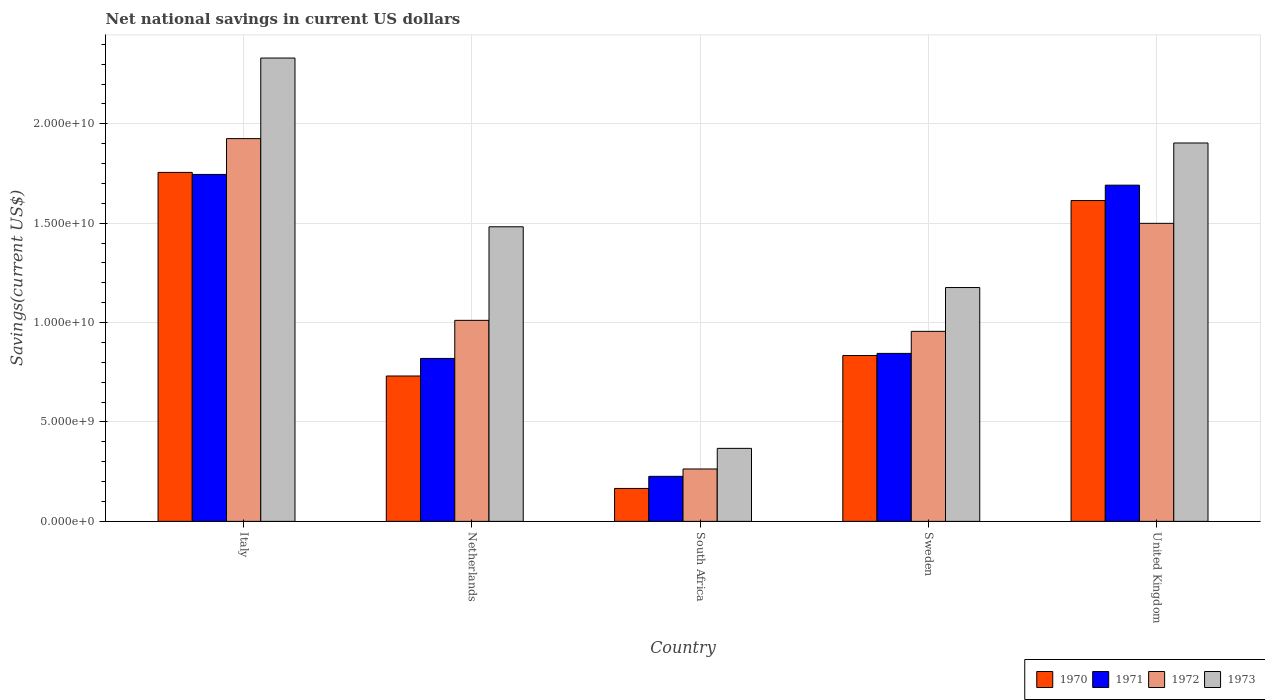How many different coloured bars are there?
Provide a short and direct response. 4. How many groups of bars are there?
Provide a succinct answer. 5. How many bars are there on the 2nd tick from the left?
Offer a terse response. 4. In how many cases, is the number of bars for a given country not equal to the number of legend labels?
Offer a terse response. 0. What is the net national savings in 1973 in Sweden?
Provide a succinct answer. 1.18e+1. Across all countries, what is the maximum net national savings in 1970?
Ensure brevity in your answer.  1.76e+1. Across all countries, what is the minimum net national savings in 1973?
Your response must be concise. 3.67e+09. In which country was the net national savings in 1970 maximum?
Offer a terse response. Italy. In which country was the net national savings in 1973 minimum?
Your answer should be compact. South Africa. What is the total net national savings in 1970 in the graph?
Your response must be concise. 5.10e+1. What is the difference between the net national savings in 1973 in South Africa and that in Sweden?
Ensure brevity in your answer.  -8.09e+09. What is the difference between the net national savings in 1972 in Sweden and the net national savings in 1973 in United Kingdom?
Make the answer very short. -9.48e+09. What is the average net national savings in 1971 per country?
Ensure brevity in your answer.  1.07e+1. What is the difference between the net national savings of/in 1971 and net national savings of/in 1972 in Italy?
Provide a short and direct response. -1.80e+09. In how many countries, is the net national savings in 1973 greater than 3000000000 US$?
Provide a succinct answer. 5. What is the ratio of the net national savings in 1972 in Netherlands to that in Sweden?
Your answer should be very brief. 1.06. Is the difference between the net national savings in 1971 in Italy and United Kingdom greater than the difference between the net national savings in 1972 in Italy and United Kingdom?
Offer a very short reply. No. What is the difference between the highest and the second highest net national savings in 1971?
Your answer should be compact. 5.40e+08. What is the difference between the highest and the lowest net national savings in 1972?
Offer a very short reply. 1.66e+1. In how many countries, is the net national savings in 1970 greater than the average net national savings in 1970 taken over all countries?
Make the answer very short. 2. Is it the case that in every country, the sum of the net national savings in 1971 and net national savings in 1972 is greater than the sum of net national savings in 1973 and net national savings in 1970?
Your answer should be compact. No. How many bars are there?
Provide a succinct answer. 20. Are all the bars in the graph horizontal?
Keep it short and to the point. No. What is the difference between two consecutive major ticks on the Y-axis?
Provide a succinct answer. 5.00e+09. How many legend labels are there?
Ensure brevity in your answer.  4. How are the legend labels stacked?
Your answer should be very brief. Horizontal. What is the title of the graph?
Offer a very short reply. Net national savings in current US dollars. What is the label or title of the X-axis?
Your answer should be very brief. Country. What is the label or title of the Y-axis?
Your answer should be compact. Savings(current US$). What is the Savings(current US$) of 1970 in Italy?
Provide a succinct answer. 1.76e+1. What is the Savings(current US$) of 1971 in Italy?
Offer a very short reply. 1.75e+1. What is the Savings(current US$) of 1972 in Italy?
Give a very brief answer. 1.93e+1. What is the Savings(current US$) in 1973 in Italy?
Give a very brief answer. 2.33e+1. What is the Savings(current US$) of 1970 in Netherlands?
Provide a succinct answer. 7.31e+09. What is the Savings(current US$) in 1971 in Netherlands?
Make the answer very short. 8.20e+09. What is the Savings(current US$) in 1972 in Netherlands?
Your answer should be very brief. 1.01e+1. What is the Savings(current US$) in 1973 in Netherlands?
Give a very brief answer. 1.48e+1. What is the Savings(current US$) of 1970 in South Africa?
Ensure brevity in your answer.  1.66e+09. What is the Savings(current US$) of 1971 in South Africa?
Ensure brevity in your answer.  2.27e+09. What is the Savings(current US$) of 1972 in South Africa?
Offer a terse response. 2.64e+09. What is the Savings(current US$) in 1973 in South Africa?
Your answer should be very brief. 3.67e+09. What is the Savings(current US$) in 1970 in Sweden?
Your answer should be very brief. 8.34e+09. What is the Savings(current US$) in 1971 in Sweden?
Provide a short and direct response. 8.45e+09. What is the Savings(current US$) in 1972 in Sweden?
Give a very brief answer. 9.56e+09. What is the Savings(current US$) in 1973 in Sweden?
Offer a terse response. 1.18e+1. What is the Savings(current US$) of 1970 in United Kingdom?
Give a very brief answer. 1.61e+1. What is the Savings(current US$) of 1971 in United Kingdom?
Your response must be concise. 1.69e+1. What is the Savings(current US$) in 1972 in United Kingdom?
Make the answer very short. 1.50e+1. What is the Savings(current US$) of 1973 in United Kingdom?
Your answer should be compact. 1.90e+1. Across all countries, what is the maximum Savings(current US$) of 1970?
Your answer should be very brief. 1.76e+1. Across all countries, what is the maximum Savings(current US$) in 1971?
Give a very brief answer. 1.75e+1. Across all countries, what is the maximum Savings(current US$) in 1972?
Ensure brevity in your answer.  1.93e+1. Across all countries, what is the maximum Savings(current US$) of 1973?
Your answer should be compact. 2.33e+1. Across all countries, what is the minimum Savings(current US$) of 1970?
Provide a succinct answer. 1.66e+09. Across all countries, what is the minimum Savings(current US$) in 1971?
Your answer should be very brief. 2.27e+09. Across all countries, what is the minimum Savings(current US$) in 1972?
Provide a succinct answer. 2.64e+09. Across all countries, what is the minimum Savings(current US$) of 1973?
Offer a terse response. 3.67e+09. What is the total Savings(current US$) in 1970 in the graph?
Keep it short and to the point. 5.10e+1. What is the total Savings(current US$) in 1971 in the graph?
Your answer should be compact. 5.33e+1. What is the total Savings(current US$) in 1972 in the graph?
Keep it short and to the point. 5.66e+1. What is the total Savings(current US$) in 1973 in the graph?
Provide a succinct answer. 7.26e+1. What is the difference between the Savings(current US$) in 1970 in Italy and that in Netherlands?
Your answer should be very brief. 1.02e+1. What is the difference between the Savings(current US$) in 1971 in Italy and that in Netherlands?
Offer a very short reply. 9.26e+09. What is the difference between the Savings(current US$) in 1972 in Italy and that in Netherlands?
Make the answer very short. 9.14e+09. What is the difference between the Savings(current US$) of 1973 in Italy and that in Netherlands?
Offer a terse response. 8.49e+09. What is the difference between the Savings(current US$) in 1970 in Italy and that in South Africa?
Make the answer very short. 1.59e+1. What is the difference between the Savings(current US$) in 1971 in Italy and that in South Africa?
Offer a terse response. 1.52e+1. What is the difference between the Savings(current US$) in 1972 in Italy and that in South Africa?
Your answer should be very brief. 1.66e+1. What is the difference between the Savings(current US$) in 1973 in Italy and that in South Africa?
Your answer should be compact. 1.96e+1. What is the difference between the Savings(current US$) in 1970 in Italy and that in Sweden?
Ensure brevity in your answer.  9.21e+09. What is the difference between the Savings(current US$) in 1971 in Italy and that in Sweden?
Your response must be concise. 9.00e+09. What is the difference between the Savings(current US$) of 1972 in Italy and that in Sweden?
Give a very brief answer. 9.70e+09. What is the difference between the Savings(current US$) of 1973 in Italy and that in Sweden?
Your answer should be compact. 1.15e+1. What is the difference between the Savings(current US$) in 1970 in Italy and that in United Kingdom?
Ensure brevity in your answer.  1.42e+09. What is the difference between the Savings(current US$) in 1971 in Italy and that in United Kingdom?
Give a very brief answer. 5.40e+08. What is the difference between the Savings(current US$) in 1972 in Italy and that in United Kingdom?
Provide a short and direct response. 4.26e+09. What is the difference between the Savings(current US$) of 1973 in Italy and that in United Kingdom?
Offer a very short reply. 4.27e+09. What is the difference between the Savings(current US$) in 1970 in Netherlands and that in South Africa?
Keep it short and to the point. 5.66e+09. What is the difference between the Savings(current US$) of 1971 in Netherlands and that in South Africa?
Keep it short and to the point. 5.93e+09. What is the difference between the Savings(current US$) in 1972 in Netherlands and that in South Africa?
Ensure brevity in your answer.  7.48e+09. What is the difference between the Savings(current US$) in 1973 in Netherlands and that in South Africa?
Ensure brevity in your answer.  1.11e+1. What is the difference between the Savings(current US$) of 1970 in Netherlands and that in Sweden?
Give a very brief answer. -1.03e+09. What is the difference between the Savings(current US$) in 1971 in Netherlands and that in Sweden?
Your answer should be very brief. -2.53e+08. What is the difference between the Savings(current US$) in 1972 in Netherlands and that in Sweden?
Give a very brief answer. 5.54e+08. What is the difference between the Savings(current US$) of 1973 in Netherlands and that in Sweden?
Your response must be concise. 3.06e+09. What is the difference between the Savings(current US$) of 1970 in Netherlands and that in United Kingdom?
Your answer should be compact. -8.83e+09. What is the difference between the Savings(current US$) of 1971 in Netherlands and that in United Kingdom?
Give a very brief answer. -8.72e+09. What is the difference between the Savings(current US$) in 1972 in Netherlands and that in United Kingdom?
Your answer should be very brief. -4.88e+09. What is the difference between the Savings(current US$) of 1973 in Netherlands and that in United Kingdom?
Offer a very short reply. -4.22e+09. What is the difference between the Savings(current US$) of 1970 in South Africa and that in Sweden?
Your answer should be very brief. -6.69e+09. What is the difference between the Savings(current US$) of 1971 in South Africa and that in Sweden?
Keep it short and to the point. -6.18e+09. What is the difference between the Savings(current US$) in 1972 in South Africa and that in Sweden?
Your response must be concise. -6.92e+09. What is the difference between the Savings(current US$) in 1973 in South Africa and that in Sweden?
Your answer should be very brief. -8.09e+09. What is the difference between the Savings(current US$) of 1970 in South Africa and that in United Kingdom?
Your response must be concise. -1.45e+1. What is the difference between the Savings(current US$) in 1971 in South Africa and that in United Kingdom?
Give a very brief answer. -1.46e+1. What is the difference between the Savings(current US$) in 1972 in South Africa and that in United Kingdom?
Make the answer very short. -1.24e+1. What is the difference between the Savings(current US$) in 1973 in South Africa and that in United Kingdom?
Your answer should be very brief. -1.54e+1. What is the difference between the Savings(current US$) of 1970 in Sweden and that in United Kingdom?
Make the answer very short. -7.80e+09. What is the difference between the Savings(current US$) of 1971 in Sweden and that in United Kingdom?
Offer a very short reply. -8.46e+09. What is the difference between the Savings(current US$) of 1972 in Sweden and that in United Kingdom?
Your answer should be very brief. -5.43e+09. What is the difference between the Savings(current US$) in 1973 in Sweden and that in United Kingdom?
Your answer should be very brief. -7.27e+09. What is the difference between the Savings(current US$) in 1970 in Italy and the Savings(current US$) in 1971 in Netherlands?
Your answer should be very brief. 9.36e+09. What is the difference between the Savings(current US$) in 1970 in Italy and the Savings(current US$) in 1972 in Netherlands?
Offer a very short reply. 7.44e+09. What is the difference between the Savings(current US$) in 1970 in Italy and the Savings(current US$) in 1973 in Netherlands?
Provide a succinct answer. 2.74e+09. What is the difference between the Savings(current US$) of 1971 in Italy and the Savings(current US$) of 1972 in Netherlands?
Offer a very short reply. 7.34e+09. What is the difference between the Savings(current US$) in 1971 in Italy and the Savings(current US$) in 1973 in Netherlands?
Your answer should be very brief. 2.63e+09. What is the difference between the Savings(current US$) in 1972 in Italy and the Savings(current US$) in 1973 in Netherlands?
Keep it short and to the point. 4.44e+09. What is the difference between the Savings(current US$) in 1970 in Italy and the Savings(current US$) in 1971 in South Africa?
Your response must be concise. 1.53e+1. What is the difference between the Savings(current US$) of 1970 in Italy and the Savings(current US$) of 1972 in South Africa?
Give a very brief answer. 1.49e+1. What is the difference between the Savings(current US$) of 1970 in Italy and the Savings(current US$) of 1973 in South Africa?
Provide a short and direct response. 1.39e+1. What is the difference between the Savings(current US$) of 1971 in Italy and the Savings(current US$) of 1972 in South Africa?
Provide a short and direct response. 1.48e+1. What is the difference between the Savings(current US$) of 1971 in Italy and the Savings(current US$) of 1973 in South Africa?
Give a very brief answer. 1.38e+1. What is the difference between the Savings(current US$) in 1972 in Italy and the Savings(current US$) in 1973 in South Africa?
Offer a terse response. 1.56e+1. What is the difference between the Savings(current US$) of 1970 in Italy and the Savings(current US$) of 1971 in Sweden?
Provide a short and direct response. 9.11e+09. What is the difference between the Savings(current US$) of 1970 in Italy and the Savings(current US$) of 1972 in Sweden?
Provide a short and direct response. 8.00e+09. What is the difference between the Savings(current US$) in 1970 in Italy and the Savings(current US$) in 1973 in Sweden?
Keep it short and to the point. 5.79e+09. What is the difference between the Savings(current US$) of 1971 in Italy and the Savings(current US$) of 1972 in Sweden?
Offer a terse response. 7.89e+09. What is the difference between the Savings(current US$) of 1971 in Italy and the Savings(current US$) of 1973 in Sweden?
Provide a succinct answer. 5.69e+09. What is the difference between the Savings(current US$) in 1972 in Italy and the Savings(current US$) in 1973 in Sweden?
Your answer should be very brief. 7.49e+09. What is the difference between the Savings(current US$) of 1970 in Italy and the Savings(current US$) of 1971 in United Kingdom?
Offer a very short reply. 6.43e+08. What is the difference between the Savings(current US$) of 1970 in Italy and the Savings(current US$) of 1972 in United Kingdom?
Offer a very short reply. 2.56e+09. What is the difference between the Savings(current US$) of 1970 in Italy and the Savings(current US$) of 1973 in United Kingdom?
Your answer should be compact. -1.48e+09. What is the difference between the Savings(current US$) in 1971 in Italy and the Savings(current US$) in 1972 in United Kingdom?
Provide a short and direct response. 2.46e+09. What is the difference between the Savings(current US$) in 1971 in Italy and the Savings(current US$) in 1973 in United Kingdom?
Your answer should be compact. -1.58e+09. What is the difference between the Savings(current US$) in 1972 in Italy and the Savings(current US$) in 1973 in United Kingdom?
Offer a very short reply. 2.20e+08. What is the difference between the Savings(current US$) of 1970 in Netherlands and the Savings(current US$) of 1971 in South Africa?
Your response must be concise. 5.05e+09. What is the difference between the Savings(current US$) of 1970 in Netherlands and the Savings(current US$) of 1972 in South Africa?
Keep it short and to the point. 4.68e+09. What is the difference between the Savings(current US$) of 1970 in Netherlands and the Savings(current US$) of 1973 in South Africa?
Your answer should be very brief. 3.64e+09. What is the difference between the Savings(current US$) in 1971 in Netherlands and the Savings(current US$) in 1972 in South Africa?
Give a very brief answer. 5.56e+09. What is the difference between the Savings(current US$) in 1971 in Netherlands and the Savings(current US$) in 1973 in South Africa?
Offer a terse response. 4.52e+09. What is the difference between the Savings(current US$) of 1972 in Netherlands and the Savings(current US$) of 1973 in South Africa?
Your answer should be compact. 6.44e+09. What is the difference between the Savings(current US$) of 1970 in Netherlands and the Savings(current US$) of 1971 in Sweden?
Give a very brief answer. -1.14e+09. What is the difference between the Savings(current US$) in 1970 in Netherlands and the Savings(current US$) in 1972 in Sweden?
Keep it short and to the point. -2.25e+09. What is the difference between the Savings(current US$) of 1970 in Netherlands and the Savings(current US$) of 1973 in Sweden?
Give a very brief answer. -4.45e+09. What is the difference between the Savings(current US$) of 1971 in Netherlands and the Savings(current US$) of 1972 in Sweden?
Give a very brief answer. -1.36e+09. What is the difference between the Savings(current US$) in 1971 in Netherlands and the Savings(current US$) in 1973 in Sweden?
Keep it short and to the point. -3.57e+09. What is the difference between the Savings(current US$) of 1972 in Netherlands and the Savings(current US$) of 1973 in Sweden?
Your answer should be very brief. -1.65e+09. What is the difference between the Savings(current US$) in 1970 in Netherlands and the Savings(current US$) in 1971 in United Kingdom?
Provide a short and direct response. -9.60e+09. What is the difference between the Savings(current US$) in 1970 in Netherlands and the Savings(current US$) in 1972 in United Kingdom?
Offer a terse response. -7.68e+09. What is the difference between the Savings(current US$) of 1970 in Netherlands and the Savings(current US$) of 1973 in United Kingdom?
Your response must be concise. -1.17e+1. What is the difference between the Savings(current US$) of 1971 in Netherlands and the Savings(current US$) of 1972 in United Kingdom?
Provide a short and direct response. -6.80e+09. What is the difference between the Savings(current US$) of 1971 in Netherlands and the Savings(current US$) of 1973 in United Kingdom?
Keep it short and to the point. -1.08e+1. What is the difference between the Savings(current US$) in 1972 in Netherlands and the Savings(current US$) in 1973 in United Kingdom?
Give a very brief answer. -8.92e+09. What is the difference between the Savings(current US$) of 1970 in South Africa and the Savings(current US$) of 1971 in Sweden?
Your response must be concise. -6.79e+09. What is the difference between the Savings(current US$) in 1970 in South Africa and the Savings(current US$) in 1972 in Sweden?
Give a very brief answer. -7.90e+09. What is the difference between the Savings(current US$) of 1970 in South Africa and the Savings(current US$) of 1973 in Sweden?
Your response must be concise. -1.01e+1. What is the difference between the Savings(current US$) of 1971 in South Africa and the Savings(current US$) of 1972 in Sweden?
Your response must be concise. -7.29e+09. What is the difference between the Savings(current US$) of 1971 in South Africa and the Savings(current US$) of 1973 in Sweden?
Give a very brief answer. -9.50e+09. What is the difference between the Savings(current US$) of 1972 in South Africa and the Savings(current US$) of 1973 in Sweden?
Keep it short and to the point. -9.13e+09. What is the difference between the Savings(current US$) of 1970 in South Africa and the Savings(current US$) of 1971 in United Kingdom?
Offer a very short reply. -1.53e+1. What is the difference between the Savings(current US$) in 1970 in South Africa and the Savings(current US$) in 1972 in United Kingdom?
Keep it short and to the point. -1.33e+1. What is the difference between the Savings(current US$) in 1970 in South Africa and the Savings(current US$) in 1973 in United Kingdom?
Give a very brief answer. -1.74e+1. What is the difference between the Savings(current US$) of 1971 in South Africa and the Savings(current US$) of 1972 in United Kingdom?
Provide a short and direct response. -1.27e+1. What is the difference between the Savings(current US$) of 1971 in South Africa and the Savings(current US$) of 1973 in United Kingdom?
Make the answer very short. -1.68e+1. What is the difference between the Savings(current US$) in 1972 in South Africa and the Savings(current US$) in 1973 in United Kingdom?
Your answer should be compact. -1.64e+1. What is the difference between the Savings(current US$) of 1970 in Sweden and the Savings(current US$) of 1971 in United Kingdom?
Your answer should be very brief. -8.57e+09. What is the difference between the Savings(current US$) in 1970 in Sweden and the Savings(current US$) in 1972 in United Kingdom?
Your answer should be compact. -6.65e+09. What is the difference between the Savings(current US$) of 1970 in Sweden and the Savings(current US$) of 1973 in United Kingdom?
Provide a succinct answer. -1.07e+1. What is the difference between the Savings(current US$) of 1971 in Sweden and the Savings(current US$) of 1972 in United Kingdom?
Make the answer very short. -6.54e+09. What is the difference between the Savings(current US$) of 1971 in Sweden and the Savings(current US$) of 1973 in United Kingdom?
Give a very brief answer. -1.06e+1. What is the difference between the Savings(current US$) of 1972 in Sweden and the Savings(current US$) of 1973 in United Kingdom?
Provide a short and direct response. -9.48e+09. What is the average Savings(current US$) in 1970 per country?
Offer a terse response. 1.02e+1. What is the average Savings(current US$) in 1971 per country?
Offer a terse response. 1.07e+1. What is the average Savings(current US$) of 1972 per country?
Ensure brevity in your answer.  1.13e+1. What is the average Savings(current US$) in 1973 per country?
Your answer should be very brief. 1.45e+1. What is the difference between the Savings(current US$) of 1970 and Savings(current US$) of 1971 in Italy?
Give a very brief answer. 1.03e+08. What is the difference between the Savings(current US$) of 1970 and Savings(current US$) of 1972 in Italy?
Provide a succinct answer. -1.70e+09. What is the difference between the Savings(current US$) in 1970 and Savings(current US$) in 1973 in Italy?
Ensure brevity in your answer.  -5.75e+09. What is the difference between the Savings(current US$) in 1971 and Savings(current US$) in 1972 in Italy?
Provide a short and direct response. -1.80e+09. What is the difference between the Savings(current US$) of 1971 and Savings(current US$) of 1973 in Italy?
Keep it short and to the point. -5.86e+09. What is the difference between the Savings(current US$) of 1972 and Savings(current US$) of 1973 in Italy?
Offer a terse response. -4.05e+09. What is the difference between the Savings(current US$) of 1970 and Savings(current US$) of 1971 in Netherlands?
Keep it short and to the point. -8.83e+08. What is the difference between the Savings(current US$) in 1970 and Savings(current US$) in 1972 in Netherlands?
Offer a very short reply. -2.80e+09. What is the difference between the Savings(current US$) in 1970 and Savings(current US$) in 1973 in Netherlands?
Your answer should be compact. -7.51e+09. What is the difference between the Savings(current US$) of 1971 and Savings(current US$) of 1972 in Netherlands?
Give a very brief answer. -1.92e+09. What is the difference between the Savings(current US$) in 1971 and Savings(current US$) in 1973 in Netherlands?
Your answer should be very brief. -6.62e+09. What is the difference between the Savings(current US$) in 1972 and Savings(current US$) in 1973 in Netherlands?
Your response must be concise. -4.71e+09. What is the difference between the Savings(current US$) of 1970 and Savings(current US$) of 1971 in South Africa?
Your answer should be very brief. -6.09e+08. What is the difference between the Savings(current US$) of 1970 and Savings(current US$) of 1972 in South Africa?
Your answer should be very brief. -9.79e+08. What is the difference between the Savings(current US$) of 1970 and Savings(current US$) of 1973 in South Africa?
Your answer should be very brief. -2.02e+09. What is the difference between the Savings(current US$) of 1971 and Savings(current US$) of 1972 in South Africa?
Keep it short and to the point. -3.70e+08. What is the difference between the Savings(current US$) of 1971 and Savings(current US$) of 1973 in South Africa?
Provide a short and direct response. -1.41e+09. What is the difference between the Savings(current US$) in 1972 and Savings(current US$) in 1973 in South Africa?
Offer a very short reply. -1.04e+09. What is the difference between the Savings(current US$) in 1970 and Savings(current US$) in 1971 in Sweden?
Your answer should be very brief. -1.07e+08. What is the difference between the Savings(current US$) in 1970 and Savings(current US$) in 1972 in Sweden?
Offer a very short reply. -1.22e+09. What is the difference between the Savings(current US$) in 1970 and Savings(current US$) in 1973 in Sweden?
Your response must be concise. -3.42e+09. What is the difference between the Savings(current US$) of 1971 and Savings(current US$) of 1972 in Sweden?
Offer a terse response. -1.11e+09. What is the difference between the Savings(current US$) in 1971 and Savings(current US$) in 1973 in Sweden?
Make the answer very short. -3.31e+09. What is the difference between the Savings(current US$) of 1972 and Savings(current US$) of 1973 in Sweden?
Give a very brief answer. -2.20e+09. What is the difference between the Savings(current US$) of 1970 and Savings(current US$) of 1971 in United Kingdom?
Keep it short and to the point. -7.74e+08. What is the difference between the Savings(current US$) of 1970 and Savings(current US$) of 1972 in United Kingdom?
Your response must be concise. 1.15e+09. What is the difference between the Savings(current US$) of 1970 and Savings(current US$) of 1973 in United Kingdom?
Keep it short and to the point. -2.90e+09. What is the difference between the Savings(current US$) of 1971 and Savings(current US$) of 1972 in United Kingdom?
Offer a very short reply. 1.92e+09. What is the difference between the Savings(current US$) in 1971 and Savings(current US$) in 1973 in United Kingdom?
Keep it short and to the point. -2.12e+09. What is the difference between the Savings(current US$) of 1972 and Savings(current US$) of 1973 in United Kingdom?
Offer a very short reply. -4.04e+09. What is the ratio of the Savings(current US$) of 1970 in Italy to that in Netherlands?
Offer a terse response. 2.4. What is the ratio of the Savings(current US$) of 1971 in Italy to that in Netherlands?
Your answer should be very brief. 2.13. What is the ratio of the Savings(current US$) of 1972 in Italy to that in Netherlands?
Give a very brief answer. 1.9. What is the ratio of the Savings(current US$) in 1973 in Italy to that in Netherlands?
Your answer should be very brief. 1.57. What is the ratio of the Savings(current US$) in 1970 in Italy to that in South Africa?
Keep it short and to the point. 10.6. What is the ratio of the Savings(current US$) of 1971 in Italy to that in South Africa?
Provide a succinct answer. 7.7. What is the ratio of the Savings(current US$) in 1972 in Italy to that in South Africa?
Provide a short and direct response. 7.31. What is the ratio of the Savings(current US$) of 1973 in Italy to that in South Africa?
Your response must be concise. 6.35. What is the ratio of the Savings(current US$) of 1970 in Italy to that in Sweden?
Give a very brief answer. 2.1. What is the ratio of the Savings(current US$) in 1971 in Italy to that in Sweden?
Your answer should be compact. 2.07. What is the ratio of the Savings(current US$) in 1972 in Italy to that in Sweden?
Provide a succinct answer. 2.01. What is the ratio of the Savings(current US$) of 1973 in Italy to that in Sweden?
Make the answer very short. 1.98. What is the ratio of the Savings(current US$) in 1970 in Italy to that in United Kingdom?
Offer a terse response. 1.09. What is the ratio of the Savings(current US$) in 1971 in Italy to that in United Kingdom?
Make the answer very short. 1.03. What is the ratio of the Savings(current US$) of 1972 in Italy to that in United Kingdom?
Provide a short and direct response. 1.28. What is the ratio of the Savings(current US$) in 1973 in Italy to that in United Kingdom?
Give a very brief answer. 1.22. What is the ratio of the Savings(current US$) in 1970 in Netherlands to that in South Africa?
Provide a short and direct response. 4.42. What is the ratio of the Savings(current US$) of 1971 in Netherlands to that in South Africa?
Your response must be concise. 3.62. What is the ratio of the Savings(current US$) in 1972 in Netherlands to that in South Africa?
Make the answer very short. 3.84. What is the ratio of the Savings(current US$) of 1973 in Netherlands to that in South Africa?
Ensure brevity in your answer.  4.04. What is the ratio of the Savings(current US$) in 1970 in Netherlands to that in Sweden?
Give a very brief answer. 0.88. What is the ratio of the Savings(current US$) in 1972 in Netherlands to that in Sweden?
Give a very brief answer. 1.06. What is the ratio of the Savings(current US$) of 1973 in Netherlands to that in Sweden?
Your answer should be very brief. 1.26. What is the ratio of the Savings(current US$) in 1970 in Netherlands to that in United Kingdom?
Offer a terse response. 0.45. What is the ratio of the Savings(current US$) of 1971 in Netherlands to that in United Kingdom?
Your answer should be compact. 0.48. What is the ratio of the Savings(current US$) of 1972 in Netherlands to that in United Kingdom?
Provide a short and direct response. 0.67. What is the ratio of the Savings(current US$) in 1973 in Netherlands to that in United Kingdom?
Keep it short and to the point. 0.78. What is the ratio of the Savings(current US$) of 1970 in South Africa to that in Sweden?
Provide a succinct answer. 0.2. What is the ratio of the Savings(current US$) of 1971 in South Africa to that in Sweden?
Your answer should be compact. 0.27. What is the ratio of the Savings(current US$) of 1972 in South Africa to that in Sweden?
Offer a terse response. 0.28. What is the ratio of the Savings(current US$) of 1973 in South Africa to that in Sweden?
Your answer should be very brief. 0.31. What is the ratio of the Savings(current US$) of 1970 in South Africa to that in United Kingdom?
Provide a short and direct response. 0.1. What is the ratio of the Savings(current US$) in 1971 in South Africa to that in United Kingdom?
Ensure brevity in your answer.  0.13. What is the ratio of the Savings(current US$) of 1972 in South Africa to that in United Kingdom?
Ensure brevity in your answer.  0.18. What is the ratio of the Savings(current US$) in 1973 in South Africa to that in United Kingdom?
Keep it short and to the point. 0.19. What is the ratio of the Savings(current US$) in 1970 in Sweden to that in United Kingdom?
Provide a short and direct response. 0.52. What is the ratio of the Savings(current US$) in 1971 in Sweden to that in United Kingdom?
Your answer should be compact. 0.5. What is the ratio of the Savings(current US$) in 1972 in Sweden to that in United Kingdom?
Provide a short and direct response. 0.64. What is the ratio of the Savings(current US$) of 1973 in Sweden to that in United Kingdom?
Ensure brevity in your answer.  0.62. What is the difference between the highest and the second highest Savings(current US$) in 1970?
Provide a succinct answer. 1.42e+09. What is the difference between the highest and the second highest Savings(current US$) of 1971?
Your answer should be very brief. 5.40e+08. What is the difference between the highest and the second highest Savings(current US$) in 1972?
Give a very brief answer. 4.26e+09. What is the difference between the highest and the second highest Savings(current US$) of 1973?
Provide a short and direct response. 4.27e+09. What is the difference between the highest and the lowest Savings(current US$) in 1970?
Offer a terse response. 1.59e+1. What is the difference between the highest and the lowest Savings(current US$) of 1971?
Give a very brief answer. 1.52e+1. What is the difference between the highest and the lowest Savings(current US$) in 1972?
Your answer should be compact. 1.66e+1. What is the difference between the highest and the lowest Savings(current US$) of 1973?
Keep it short and to the point. 1.96e+1. 